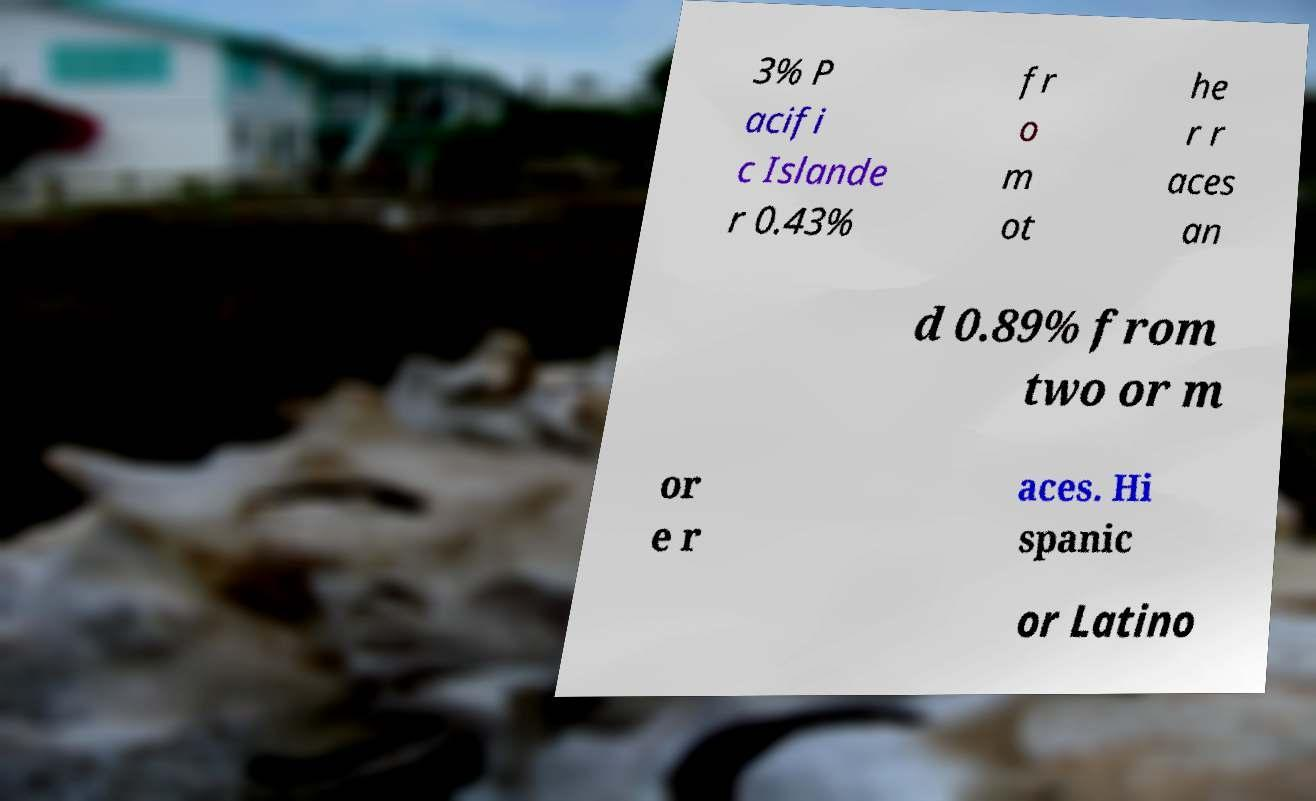Can you read and provide the text displayed in the image?This photo seems to have some interesting text. Can you extract and type it out for me? 3% P acifi c Islande r 0.43% fr o m ot he r r aces an d 0.89% from two or m or e r aces. Hi spanic or Latino 